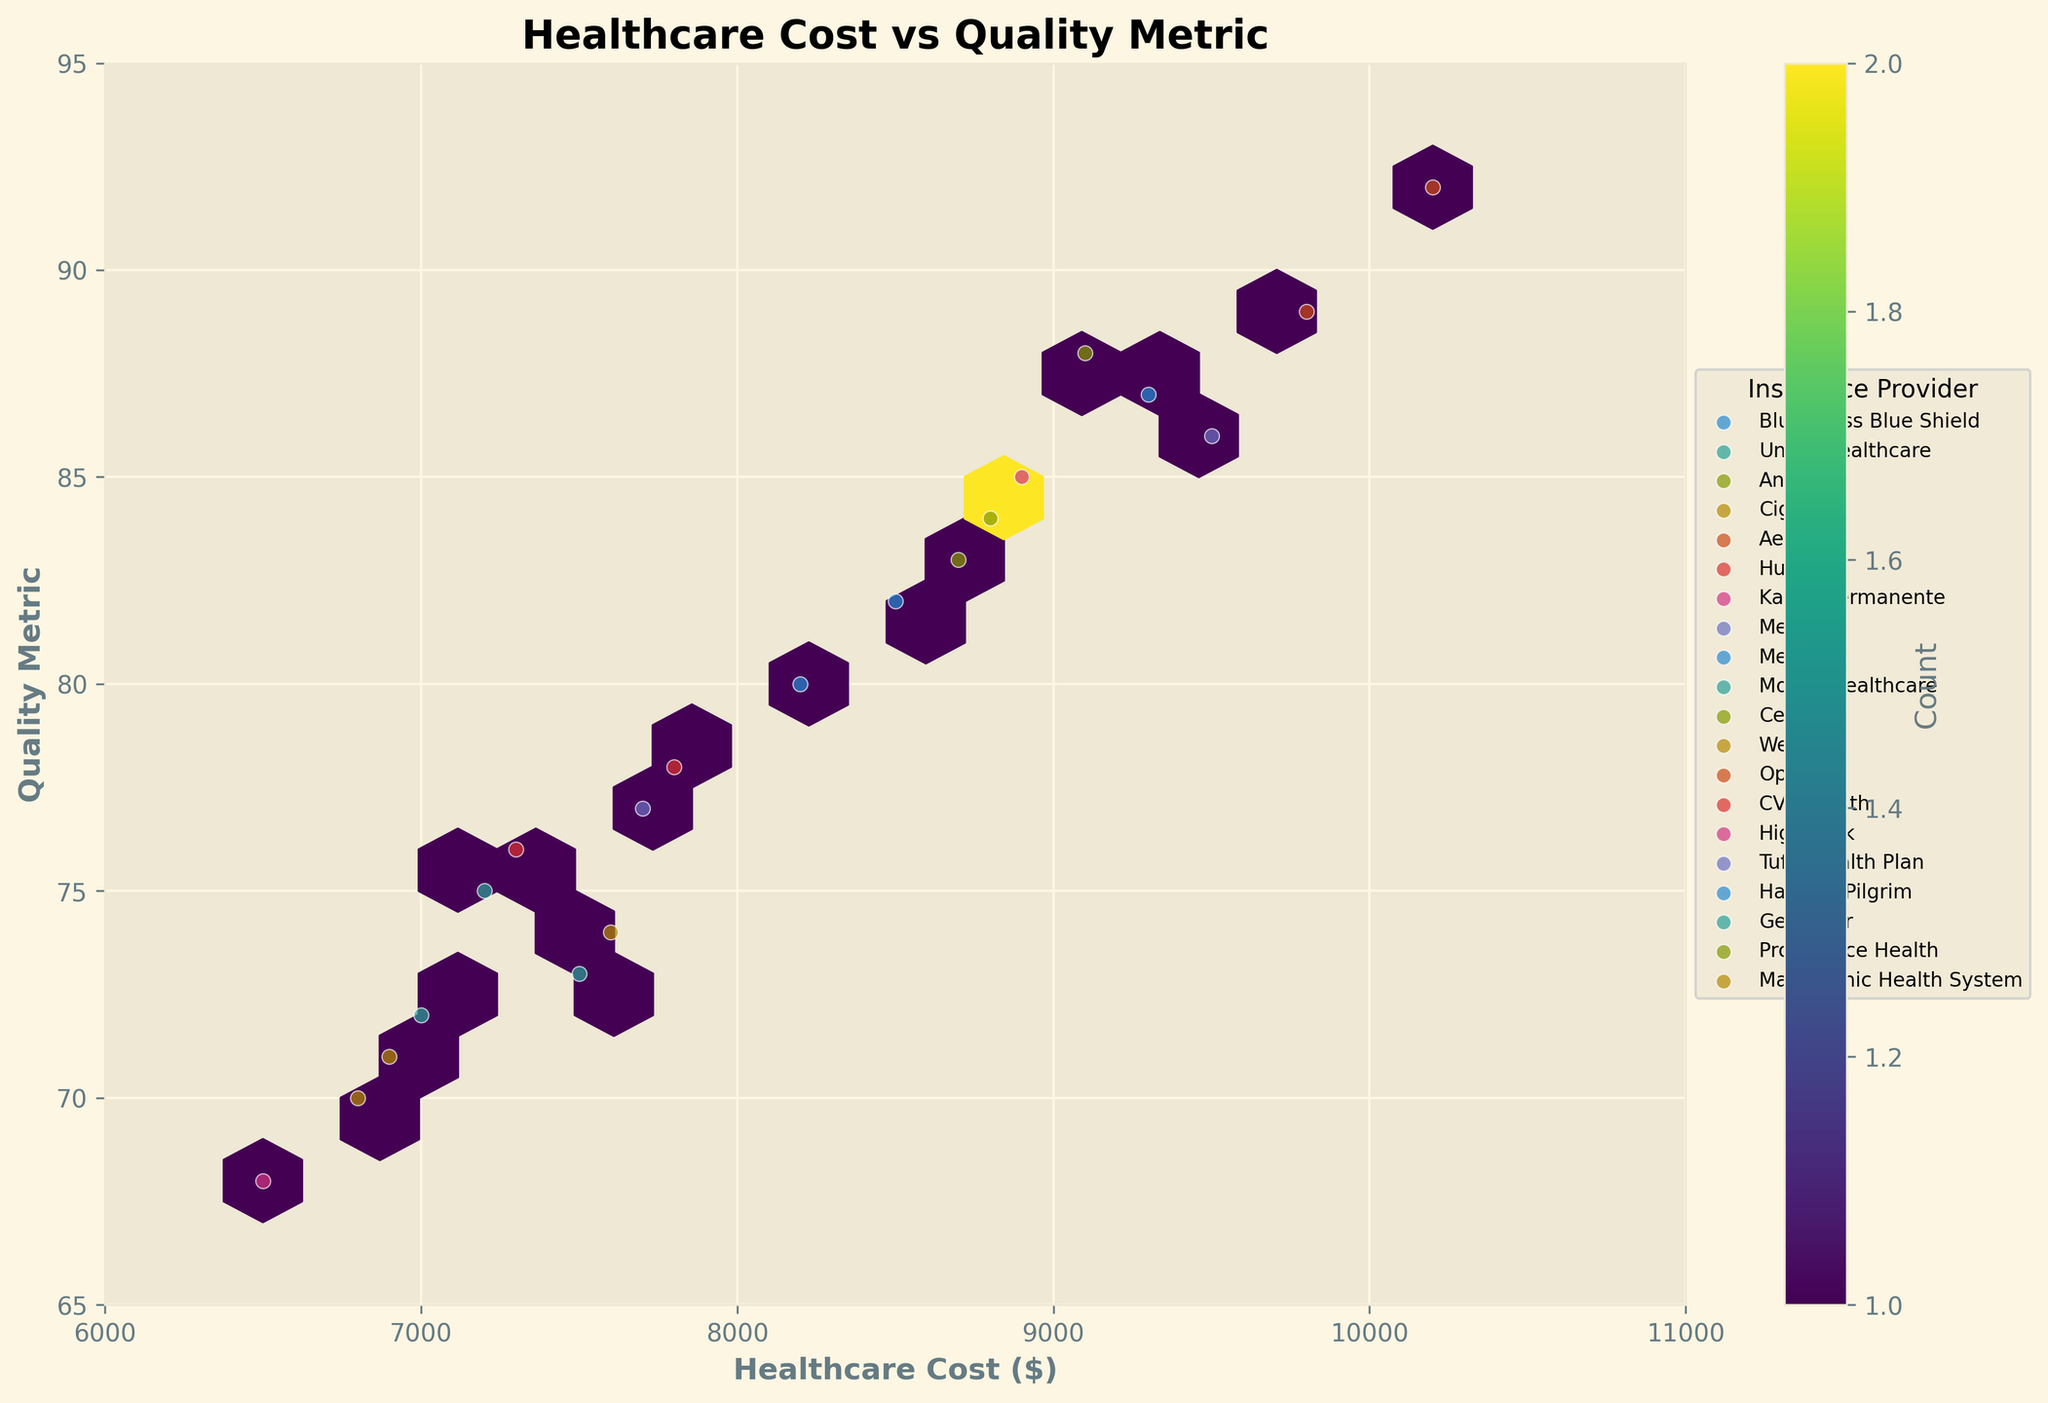What's the title of the figure? The title is positioned at the top of the figure and often gives a brief description of what the plot represents. In this case, it's "Healthcare Cost vs Quality Metric".
Answer: Healthcare Cost vs Quality Metric What are the x and y axes labeled as? The x and y axes are labeled to indicate what each axis represents. The x-axis is labeled "Healthcare Cost ($)" and the y-axis is labeled "Quality Metric".
Answer: Healthcare Cost ($) and Quality Metric Which insurance provider appears to have the highest quality metric? By identifying the scatter points and their corresponding labels at the upper end of the y-axis, we can see that Aetna has a Quality Metric of 92.
Answer: Aetna What is the range of healthcare costs shown in the plot? The x-axis ranges from 6000 to 11000, as can be seen from the limits set on the x-axis.
Answer: 6000 to 11000 Which insurance provider has the lowest quality metric? By identifying the scatter points and their corresponding labels at the lower end of the y-axis, we see that Kaiser Permanente has a Quality Metric of 68.
Answer: Kaiser Permanente How many hexagonal bins are there on the plot? The number of hexagonal bins can be approximated by counting the individual hexagons visible within the plot area. This may require visual scanning across the plot.
Answer: Approximately 15 Do higher healthcare costs generally correlate with higher quality metrics? By observing the overall distribution and pattern of the hexagons, most of them are clustered towards the upper right, indicating that higher costs generally associate with higher quality metrics.
Answer: Yes How many insurance providers have a quality metric above 85? By scanning the individual points labeled on the y-axis above the value of 85, we can count how many insurance providers fall into this range. Aetna, Anthem, Harvard Pilgrim, Medicaid, Optum, and Highmark are above 85.
Answer: 6 Which hospital type has the highest associated healthcare cost, and what is that cost? By identifying the point with the highest x-axis value and its corresponding label, we see that the Specialized Cancer Center has the highest healthcare cost of 10200.
Answer: Specialized Cancer Center, 10200 What is the color scheme used for the hexbin plot, and what does the color intensity represent? The color scheme used is 'viridis', a perceptually-uniform colormap, and the color intensity represents the count of data points within each hexagonal bin. Higher intensity means more data points in that bin.
Answer: Viridis, Count 